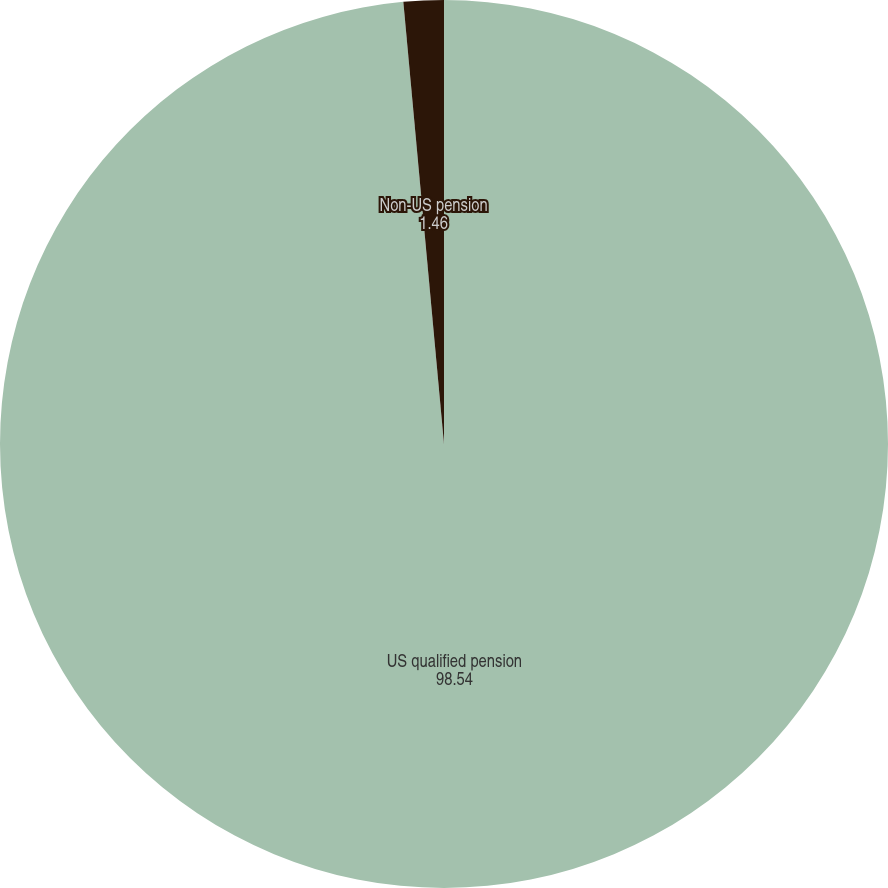Convert chart to OTSL. <chart><loc_0><loc_0><loc_500><loc_500><pie_chart><fcel>US qualified pension<fcel>Non-US pension<nl><fcel>98.54%<fcel>1.46%<nl></chart> 